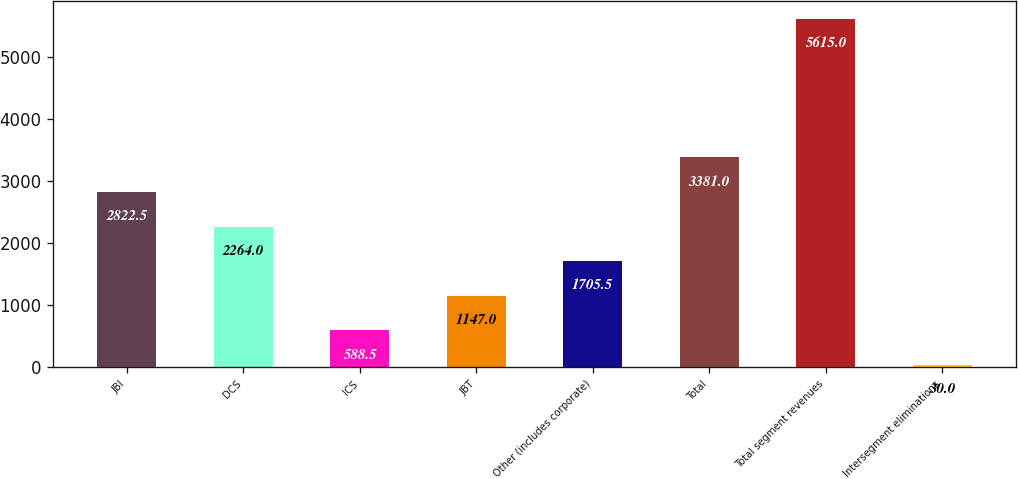Convert chart to OTSL. <chart><loc_0><loc_0><loc_500><loc_500><bar_chart><fcel>JBI<fcel>DCS<fcel>ICS<fcel>JBT<fcel>Other (includes corporate)<fcel>Total<fcel>Total segment revenues<fcel>Intersegment eliminations<nl><fcel>2822.5<fcel>2264<fcel>588.5<fcel>1147<fcel>1705.5<fcel>3381<fcel>5615<fcel>30<nl></chart> 